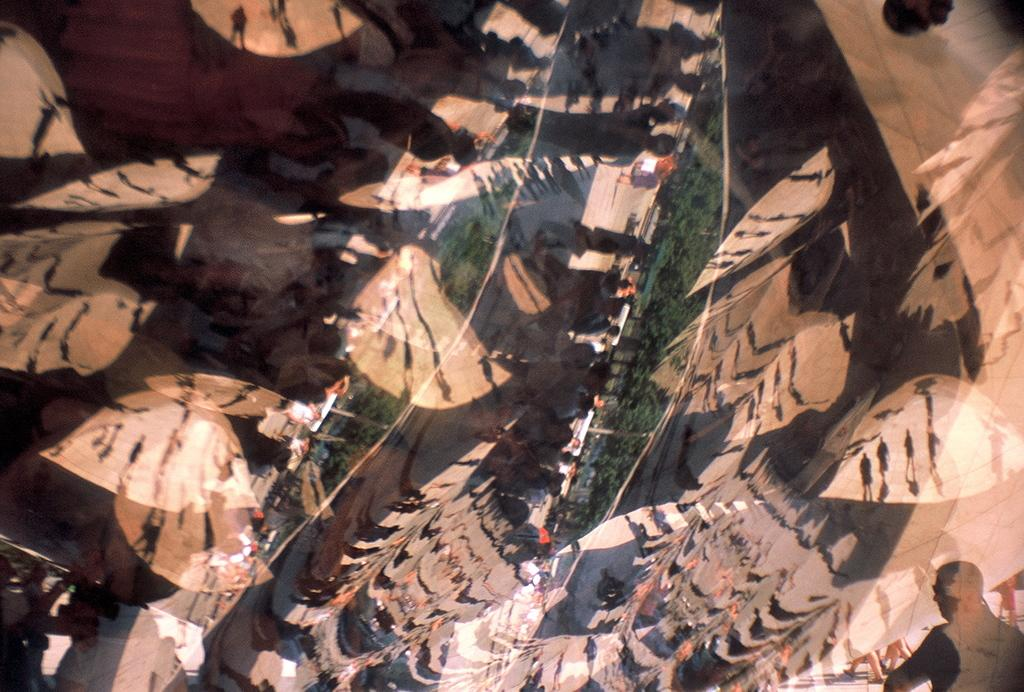What is located in the foreground of the image? There is a glass door in the foreground of the image. What can be seen in the reflection on the glass door? The reflection on the glass door shows people, trees, and objects. How does the glass door make a request for more light in the image? The glass door does not make a request for more light in the image; it is an inanimate object and cannot communicate or make requests. 